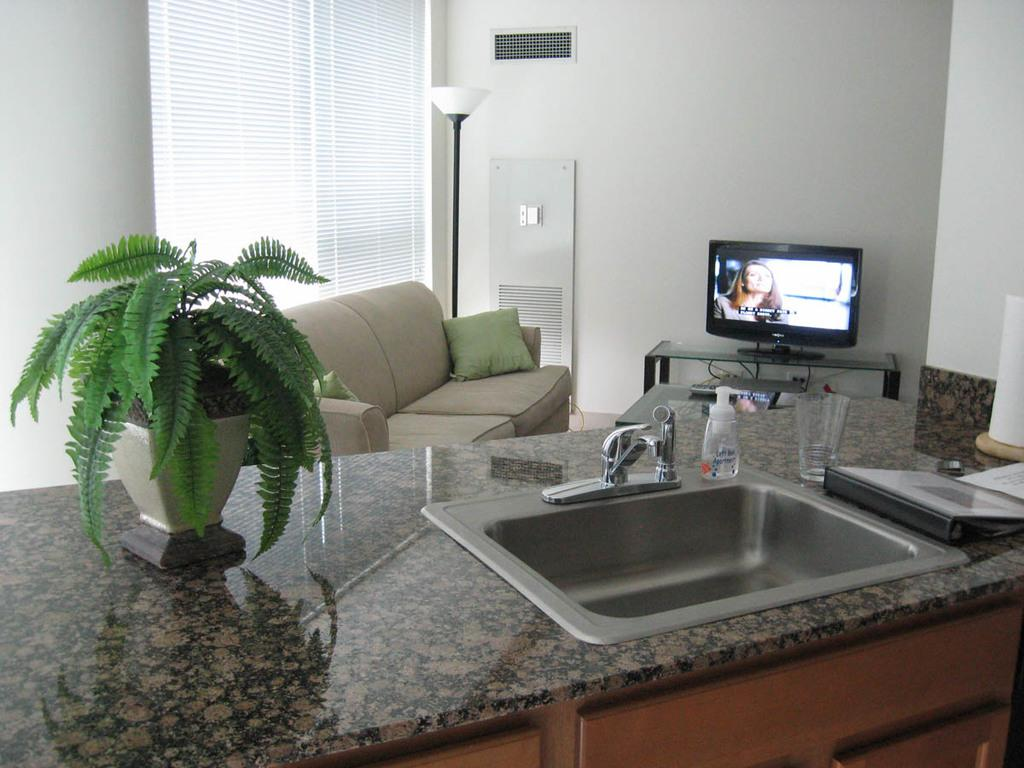What type of furniture is present in the room? There is a sofa with a pillow in the room. What is another object that provides light in the room? There is a lamp in the room. What electronic device can be found on a table in the room? There is a TV on a table in the room. What is a fixture typically used for washing hands in the room? There is a wash basin in the room. What type of decorative item can be found in the room? There is a flower vase in the room. What type of amusement can be found in the room? There is no amusement mentioned in the room; the provided facts only mention a sofa, lamp, TV, wash basin, and flower vase. What type of brick is used to construct the wall in the room? The provided facts do not mention any bricks or construction materials used in the room. 